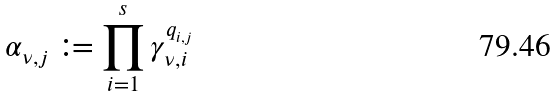<formula> <loc_0><loc_0><loc_500><loc_500>\alpha _ { \nu , j } \coloneqq \prod _ { i = 1 } ^ { s } \gamma _ { \nu , i } ^ { q _ { i , j } }</formula> 